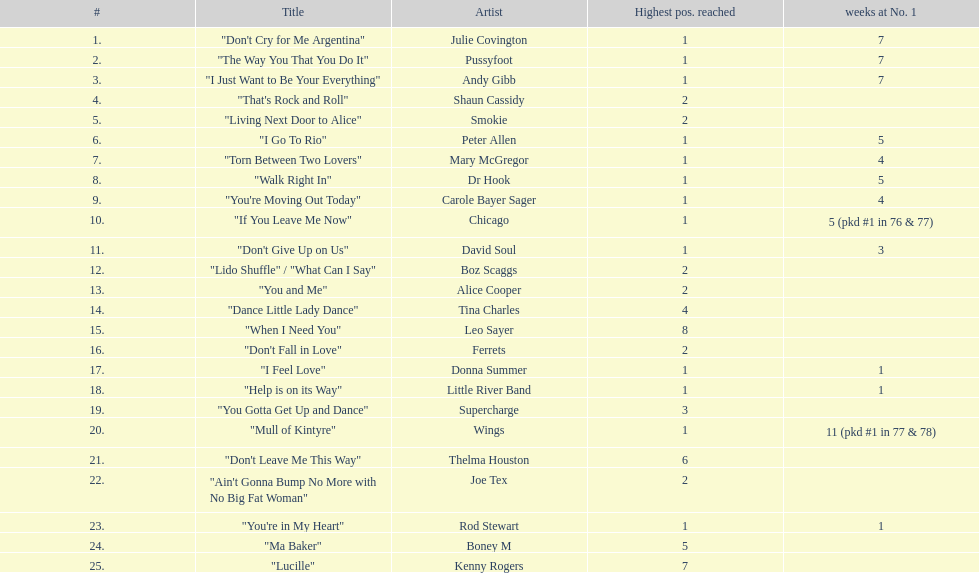According to the table, who had the maximum number of weeks at the first place? Wings. 